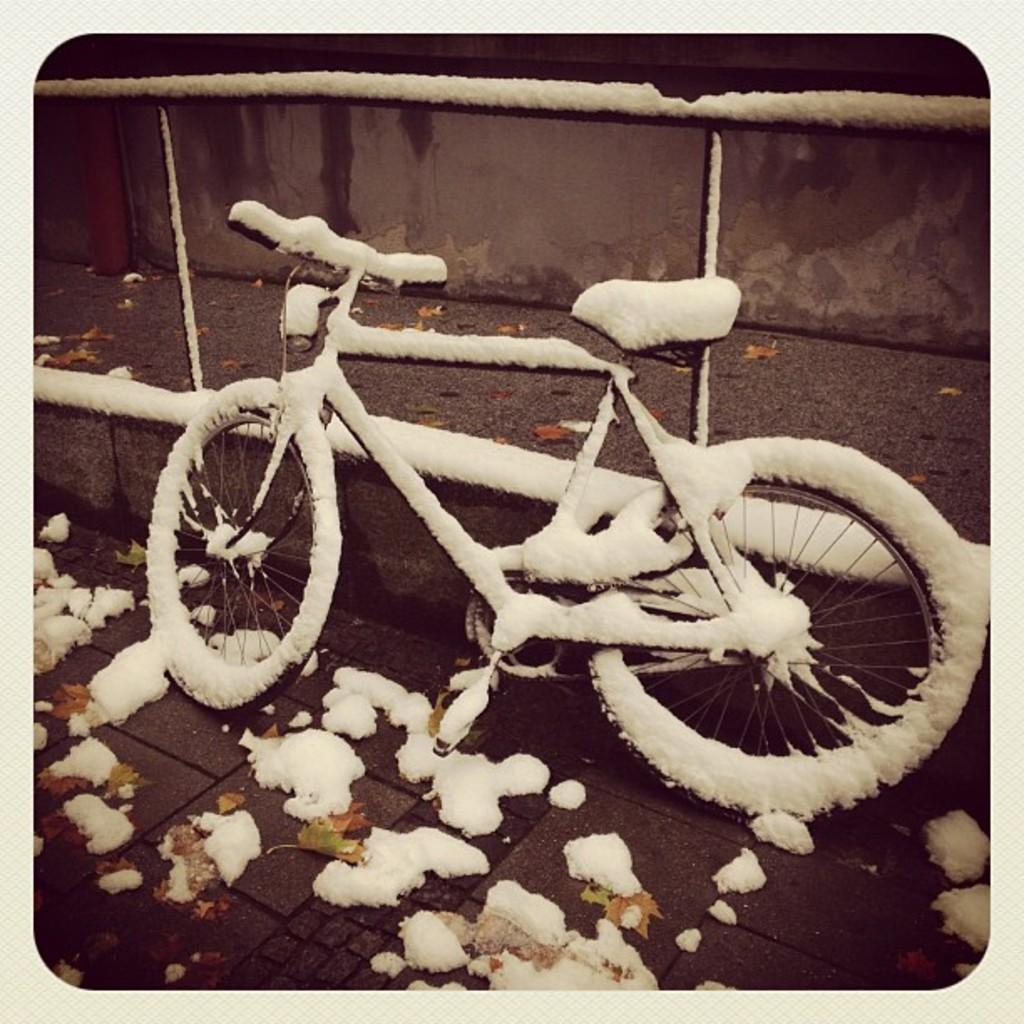What is the main subject of the image? The main subject of the image is a bicycle. How is the bicycle affected by the weather? The bicycle is covered with snow. What colors can be seen on the background wall? The background wall is in brown and black colors. What type of sea creature can be seen crawling on the bicycle in the image? There is no sea creature present in the image; the bicycle is covered with snow. 